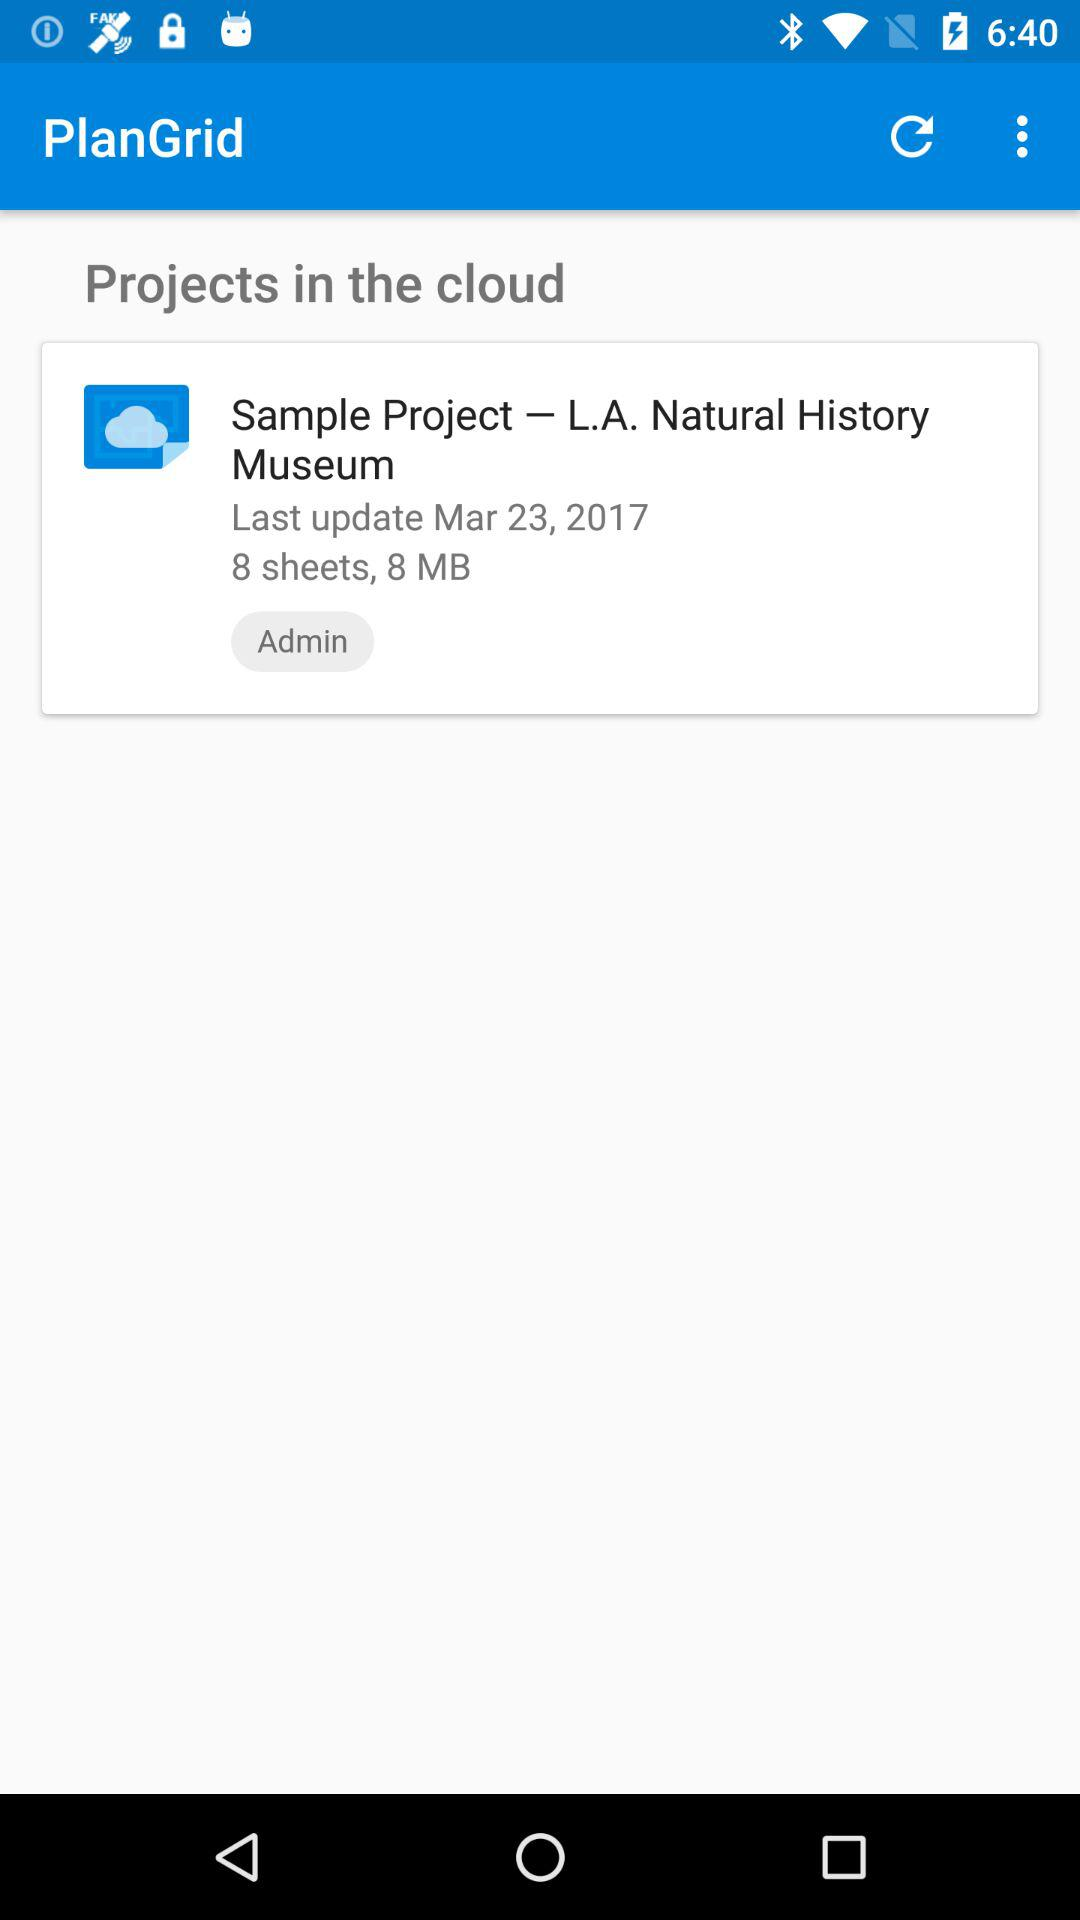How many MB is the project?
Answer the question using a single word or phrase. 8 